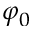Convert formula to latex. <formula><loc_0><loc_0><loc_500><loc_500>\varphi _ { 0 }</formula> 